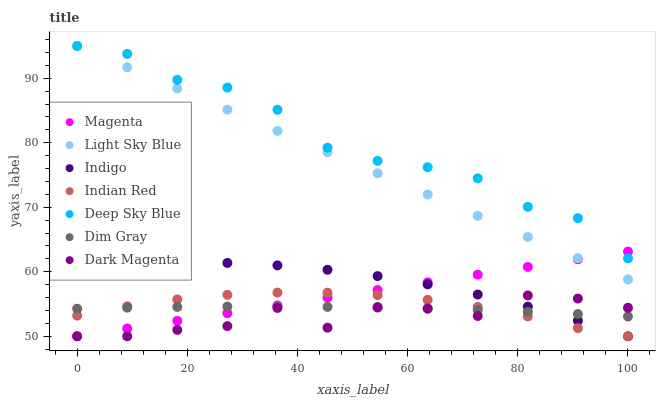Does Dark Magenta have the minimum area under the curve?
Answer yes or no. Yes. Does Deep Sky Blue have the maximum area under the curve?
Answer yes or no. Yes. Does Indigo have the minimum area under the curve?
Answer yes or no. No. Does Indigo have the maximum area under the curve?
Answer yes or no. No. Is Light Sky Blue the smoothest?
Answer yes or no. Yes. Is Dark Magenta the roughest?
Answer yes or no. Yes. Is Indigo the smoothest?
Answer yes or no. No. Is Indigo the roughest?
Answer yes or no. No. Does Indigo have the lowest value?
Answer yes or no. Yes. Does Light Sky Blue have the lowest value?
Answer yes or no. No. Does Deep Sky Blue have the highest value?
Answer yes or no. Yes. Does Indigo have the highest value?
Answer yes or no. No. Is Dark Magenta less than Light Sky Blue?
Answer yes or no. Yes. Is Light Sky Blue greater than Dim Gray?
Answer yes or no. Yes. Does Dim Gray intersect Dark Magenta?
Answer yes or no. Yes. Is Dim Gray less than Dark Magenta?
Answer yes or no. No. Is Dim Gray greater than Dark Magenta?
Answer yes or no. No. Does Dark Magenta intersect Light Sky Blue?
Answer yes or no. No. 